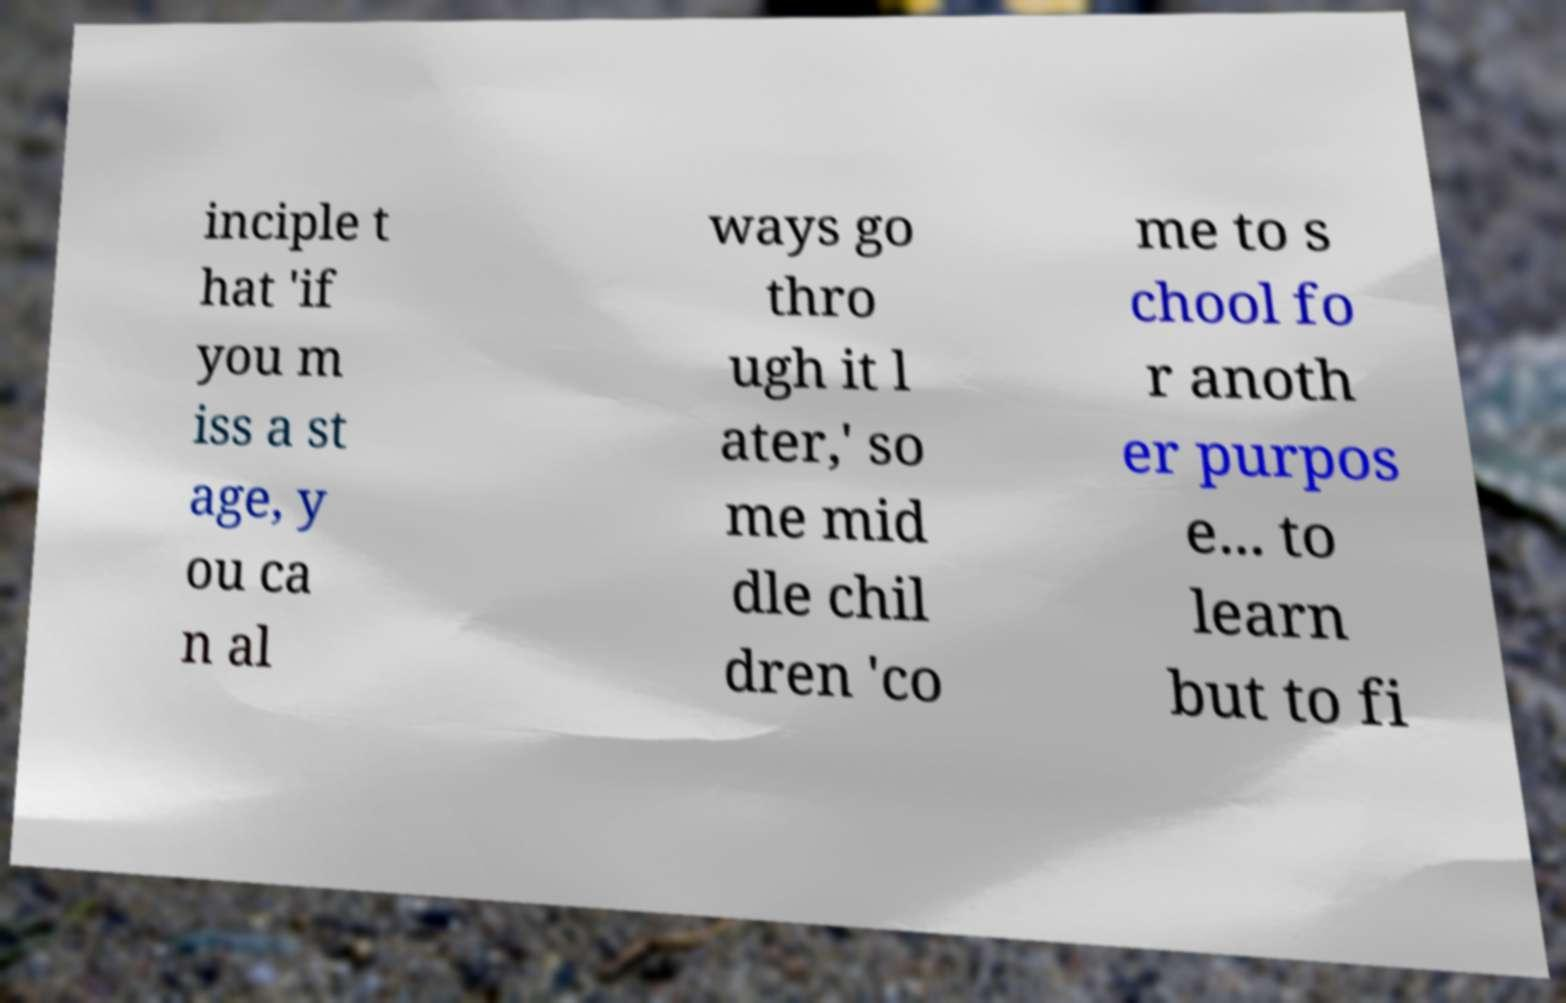Please identify and transcribe the text found in this image. inciple t hat 'if you m iss a st age, y ou ca n al ways go thro ugh it l ater,' so me mid dle chil dren 'co me to s chool fo r anoth er purpos e... to learn but to fi 